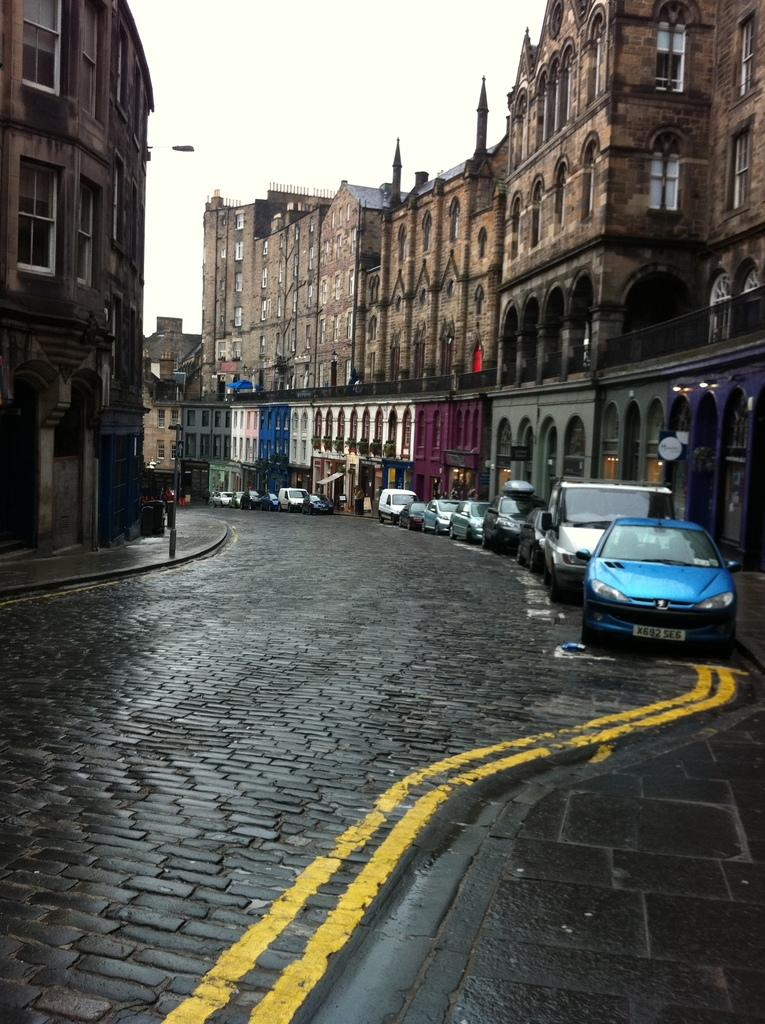<image>
Relay a brief, clear account of the picture shown. A blue car with a license plate that begins with X692 is parked at the curb. 